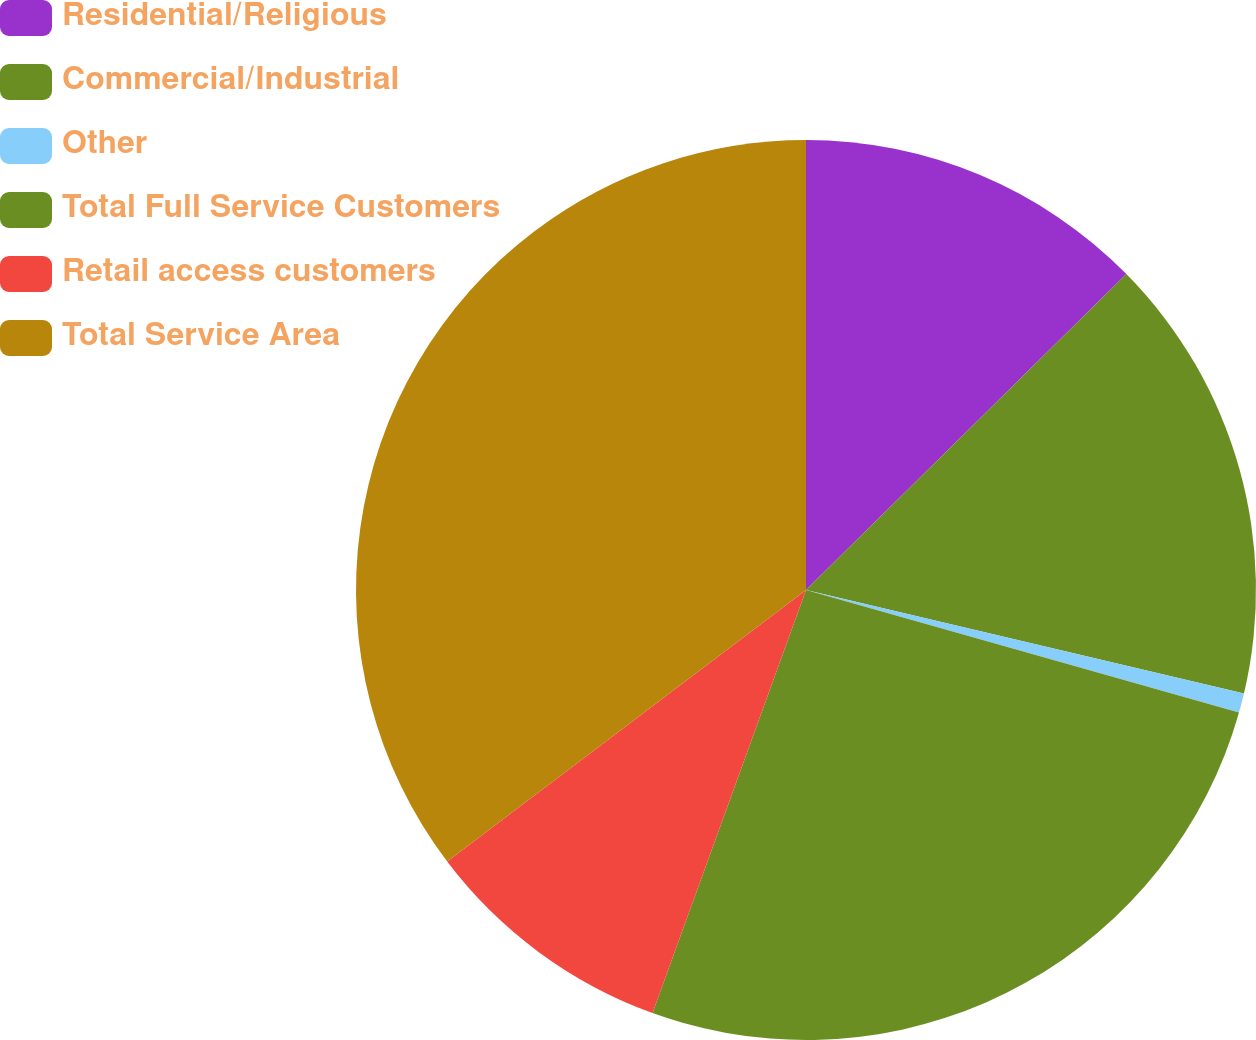<chart> <loc_0><loc_0><loc_500><loc_500><pie_chart><fcel>Residential/Religious<fcel>Commercial/Industrial<fcel>Other<fcel>Total Full Service Customers<fcel>Retail access customers<fcel>Total Service Area<nl><fcel>12.61%<fcel>16.08%<fcel>0.7%<fcel>26.15%<fcel>9.15%<fcel>35.31%<nl></chart> 